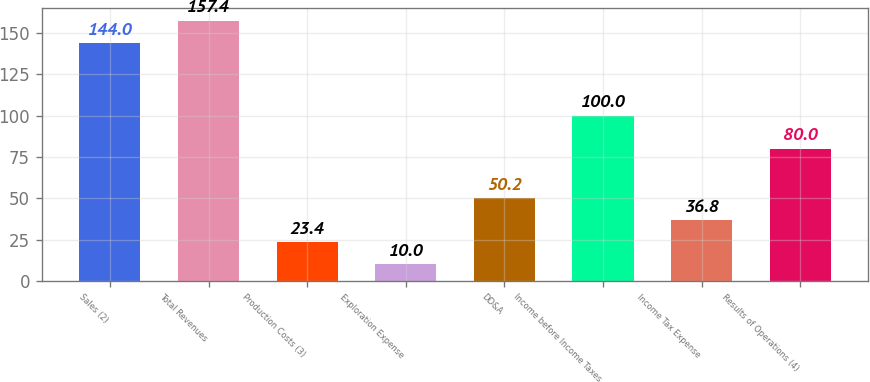<chart> <loc_0><loc_0><loc_500><loc_500><bar_chart><fcel>Sales (2)<fcel>Total Revenues<fcel>Production Costs (3)<fcel>Exploration Expense<fcel>DD&A<fcel>Income before Income Taxes<fcel>Income Tax Expense<fcel>Results of Operations (4)<nl><fcel>144<fcel>157.4<fcel>23.4<fcel>10<fcel>50.2<fcel>100<fcel>36.8<fcel>80<nl></chart> 